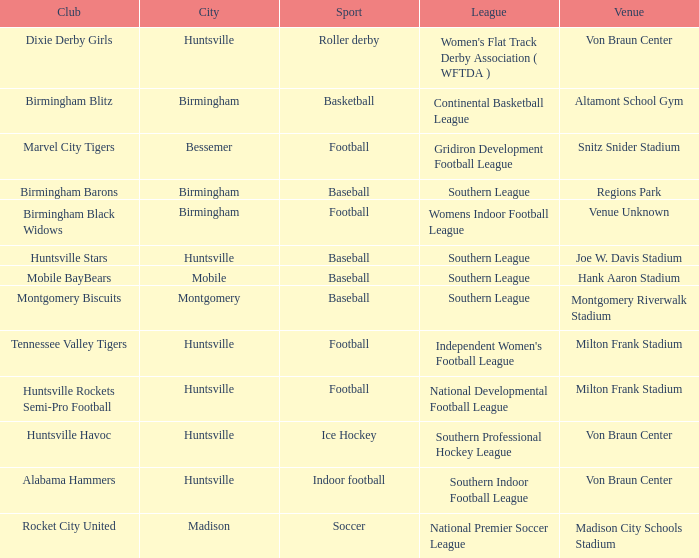In which sport were the montgomery biscuits club involved? Baseball. 